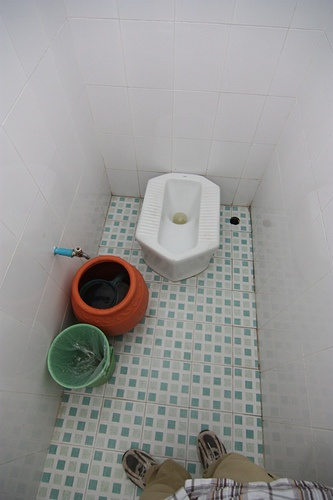Describe the objects in this image and their specific colors. I can see toilet in darkgray, lightgray, and gray tones and people in darkgray, gray, and black tones in this image. 